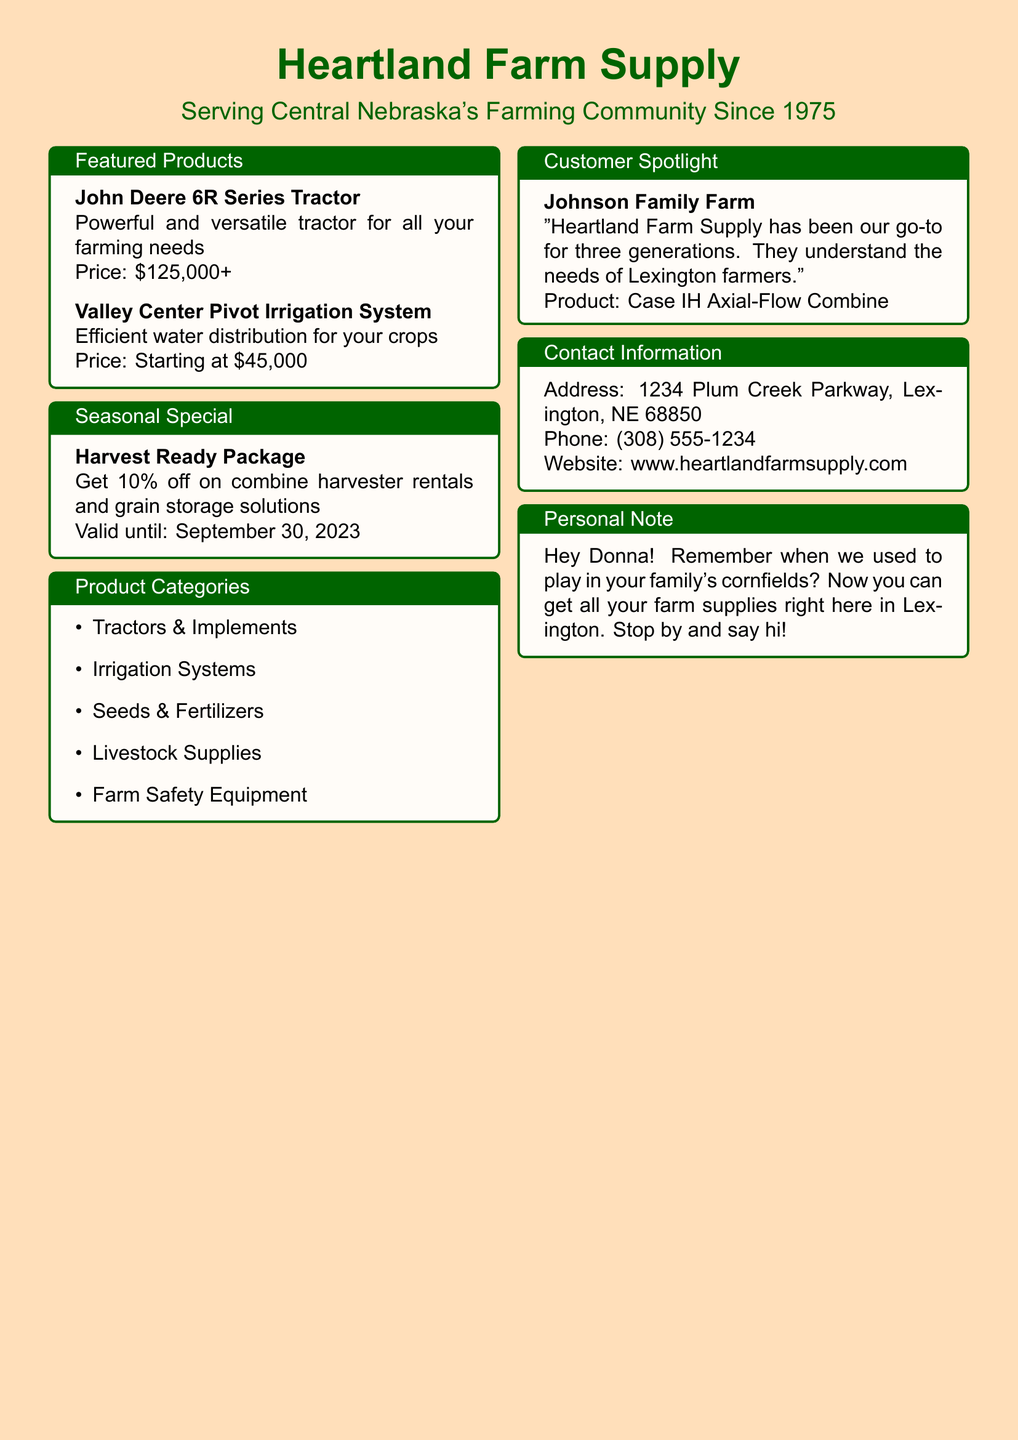what is the name of the catalog? The catalog is titled "Heartland Farm Supply."
Answer: Heartland Farm Supply when was the catalog established? The catalog has been serving since 1975.
Answer: 1975 what is the price of the John Deere 6R Series Tractor? The price for the John Deere 6R Series Tractor is listed as starting at $125,000.
Answer: $125,000+ what special offer is currently available? The current special offer is a 10% discount on combine harvester rentals and grain storage solutions.
Answer: 10% off who is featured in the customer spotlight? The customer spotlight features Johnson Family Farm.
Answer: Johnson Family Farm what is the address of Heartland Farm Supply? The address of Heartland Farm Supply is 1234 Plum Creek Parkway, Lexington, NE 68850.
Answer: 1234 Plum Creek Parkway, Lexington, NE 68850 which product category does not appear in the catalog? The product categories listed include Tractors & Implements, Irrigation Systems, Seeds & Fertilizers, Livestock Supplies, and Farm Safety Equipment; none are omitted here.
Answer: None until when is the seasonal special valid? The seasonal special is valid until September 30, 2023.
Answer: September 30, 2023 what product is highlighted in the seasonal special? The highlighted product in the seasonal special is the combine harvester.
Answer: combine harvester 